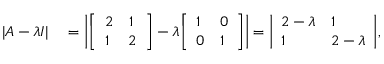Convert formula to latex. <formula><loc_0><loc_0><loc_500><loc_500>\begin{array} { r l } { | A - \lambda I | } & = \left | { \left [ \begin{array} { l l } { 2 } & { 1 } \\ { 1 } & { 2 } \end{array} \right ] } - \lambda { \left [ \begin{array} { l l } { 1 } & { 0 } \\ { 0 } & { 1 } \end{array} \right ] } \right | = { \left | \begin{array} { l l } { 2 - \lambda } & { 1 } \\ { 1 } & { 2 - \lambda } \end{array} \right | } , } \end{array}</formula> 